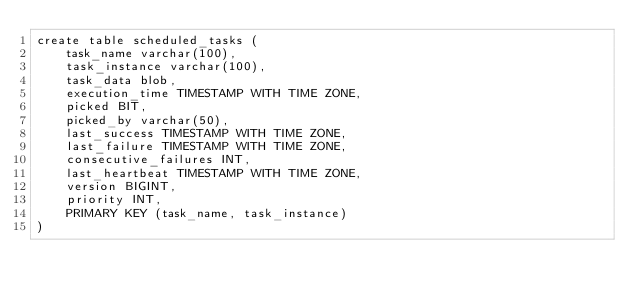<code> <loc_0><loc_0><loc_500><loc_500><_SQL_>create table scheduled_tasks (
    task_name varchar(100),
    task_instance varchar(100),
    task_data blob,
    execution_time TIMESTAMP WITH TIME ZONE,
    picked BIT,
    picked_by varchar(50),
    last_success TIMESTAMP WITH TIME ZONE,
    last_failure TIMESTAMP WITH TIME ZONE,
    consecutive_failures INT,
    last_heartbeat TIMESTAMP WITH TIME ZONE,
    version BIGINT,
    priority INT,
    PRIMARY KEY (task_name, task_instance)
)
</code> 